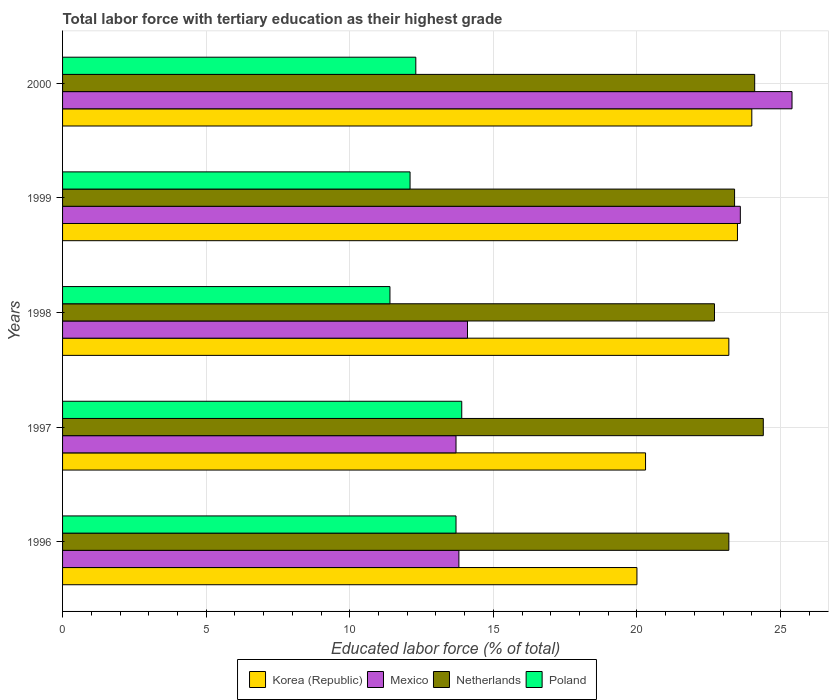How many different coloured bars are there?
Your answer should be compact. 4. How many groups of bars are there?
Your answer should be compact. 5. Are the number of bars per tick equal to the number of legend labels?
Make the answer very short. Yes. In how many cases, is the number of bars for a given year not equal to the number of legend labels?
Make the answer very short. 0. What is the percentage of male labor force with tertiary education in Mexico in 1997?
Offer a very short reply. 13.7. Across all years, what is the maximum percentage of male labor force with tertiary education in Korea (Republic)?
Offer a very short reply. 24. Across all years, what is the minimum percentage of male labor force with tertiary education in Mexico?
Give a very brief answer. 13.7. In which year was the percentage of male labor force with tertiary education in Poland maximum?
Offer a very short reply. 1997. In which year was the percentage of male labor force with tertiary education in Mexico minimum?
Offer a very short reply. 1997. What is the total percentage of male labor force with tertiary education in Poland in the graph?
Make the answer very short. 63.4. What is the difference between the percentage of male labor force with tertiary education in Poland in 1996 and that in 1998?
Offer a very short reply. 2.3. What is the difference between the percentage of male labor force with tertiary education in Mexico in 1996 and the percentage of male labor force with tertiary education in Netherlands in 1998?
Ensure brevity in your answer.  -8.9. In the year 1998, what is the difference between the percentage of male labor force with tertiary education in Netherlands and percentage of male labor force with tertiary education in Poland?
Ensure brevity in your answer.  11.3. What is the ratio of the percentage of male labor force with tertiary education in Poland in 1997 to that in 1998?
Offer a terse response. 1.22. Is the percentage of male labor force with tertiary education in Mexico in 1997 less than that in 2000?
Make the answer very short. Yes. What is the difference between the highest and the second highest percentage of male labor force with tertiary education in Korea (Republic)?
Provide a short and direct response. 0.5. What is the difference between the highest and the lowest percentage of male labor force with tertiary education in Korea (Republic)?
Make the answer very short. 4. Is the sum of the percentage of male labor force with tertiary education in Mexico in 1996 and 1997 greater than the maximum percentage of male labor force with tertiary education in Poland across all years?
Provide a succinct answer. Yes. Is it the case that in every year, the sum of the percentage of male labor force with tertiary education in Poland and percentage of male labor force with tertiary education in Korea (Republic) is greater than the sum of percentage of male labor force with tertiary education in Mexico and percentage of male labor force with tertiary education in Netherlands?
Your answer should be very brief. Yes. Are all the bars in the graph horizontal?
Your answer should be very brief. Yes. What is the difference between two consecutive major ticks on the X-axis?
Ensure brevity in your answer.  5. Does the graph contain any zero values?
Make the answer very short. No. Does the graph contain grids?
Provide a succinct answer. Yes. How many legend labels are there?
Provide a succinct answer. 4. How are the legend labels stacked?
Your answer should be compact. Horizontal. What is the title of the graph?
Offer a very short reply. Total labor force with tertiary education as their highest grade. Does "Niger" appear as one of the legend labels in the graph?
Offer a terse response. No. What is the label or title of the X-axis?
Your response must be concise. Educated labor force (% of total). What is the label or title of the Y-axis?
Your answer should be compact. Years. What is the Educated labor force (% of total) in Mexico in 1996?
Make the answer very short. 13.8. What is the Educated labor force (% of total) of Netherlands in 1996?
Your response must be concise. 23.2. What is the Educated labor force (% of total) in Poland in 1996?
Your response must be concise. 13.7. What is the Educated labor force (% of total) in Korea (Republic) in 1997?
Your answer should be very brief. 20.3. What is the Educated labor force (% of total) in Mexico in 1997?
Ensure brevity in your answer.  13.7. What is the Educated labor force (% of total) of Netherlands in 1997?
Ensure brevity in your answer.  24.4. What is the Educated labor force (% of total) of Poland in 1997?
Keep it short and to the point. 13.9. What is the Educated labor force (% of total) of Korea (Republic) in 1998?
Provide a succinct answer. 23.2. What is the Educated labor force (% of total) in Mexico in 1998?
Your answer should be compact. 14.1. What is the Educated labor force (% of total) in Netherlands in 1998?
Provide a short and direct response. 22.7. What is the Educated labor force (% of total) in Poland in 1998?
Your answer should be very brief. 11.4. What is the Educated labor force (% of total) in Korea (Republic) in 1999?
Your answer should be compact. 23.5. What is the Educated labor force (% of total) of Mexico in 1999?
Make the answer very short. 23.6. What is the Educated labor force (% of total) of Netherlands in 1999?
Offer a very short reply. 23.4. What is the Educated labor force (% of total) in Poland in 1999?
Give a very brief answer. 12.1. What is the Educated labor force (% of total) in Korea (Republic) in 2000?
Give a very brief answer. 24. What is the Educated labor force (% of total) of Mexico in 2000?
Offer a very short reply. 25.4. What is the Educated labor force (% of total) of Netherlands in 2000?
Provide a succinct answer. 24.1. What is the Educated labor force (% of total) of Poland in 2000?
Your answer should be compact. 12.3. Across all years, what is the maximum Educated labor force (% of total) of Korea (Republic)?
Offer a very short reply. 24. Across all years, what is the maximum Educated labor force (% of total) in Mexico?
Keep it short and to the point. 25.4. Across all years, what is the maximum Educated labor force (% of total) of Netherlands?
Your answer should be very brief. 24.4. Across all years, what is the maximum Educated labor force (% of total) of Poland?
Provide a succinct answer. 13.9. Across all years, what is the minimum Educated labor force (% of total) in Korea (Republic)?
Make the answer very short. 20. Across all years, what is the minimum Educated labor force (% of total) of Mexico?
Provide a short and direct response. 13.7. Across all years, what is the minimum Educated labor force (% of total) of Netherlands?
Provide a succinct answer. 22.7. Across all years, what is the minimum Educated labor force (% of total) in Poland?
Provide a succinct answer. 11.4. What is the total Educated labor force (% of total) in Korea (Republic) in the graph?
Offer a terse response. 111. What is the total Educated labor force (% of total) in Mexico in the graph?
Your response must be concise. 90.6. What is the total Educated labor force (% of total) in Netherlands in the graph?
Your answer should be very brief. 117.8. What is the total Educated labor force (% of total) in Poland in the graph?
Offer a terse response. 63.4. What is the difference between the Educated labor force (% of total) of Korea (Republic) in 1996 and that in 1997?
Give a very brief answer. -0.3. What is the difference between the Educated labor force (% of total) in Mexico in 1996 and that in 1997?
Provide a short and direct response. 0.1. What is the difference between the Educated labor force (% of total) of Poland in 1996 and that in 1997?
Give a very brief answer. -0.2. What is the difference between the Educated labor force (% of total) of Korea (Republic) in 1996 and that in 1998?
Your answer should be compact. -3.2. What is the difference between the Educated labor force (% of total) in Netherlands in 1996 and that in 1998?
Your answer should be very brief. 0.5. What is the difference between the Educated labor force (% of total) of Poland in 1996 and that in 1998?
Make the answer very short. 2.3. What is the difference between the Educated labor force (% of total) of Korea (Republic) in 1996 and that in 1999?
Make the answer very short. -3.5. What is the difference between the Educated labor force (% of total) of Mexico in 1996 and that in 1999?
Your response must be concise. -9.8. What is the difference between the Educated labor force (% of total) in Poland in 1996 and that in 1999?
Your response must be concise. 1.6. What is the difference between the Educated labor force (% of total) in Korea (Republic) in 1996 and that in 2000?
Your answer should be very brief. -4. What is the difference between the Educated labor force (% of total) of Netherlands in 1996 and that in 2000?
Ensure brevity in your answer.  -0.9. What is the difference between the Educated labor force (% of total) of Poland in 1996 and that in 2000?
Offer a terse response. 1.4. What is the difference between the Educated labor force (% of total) of Korea (Republic) in 1997 and that in 1999?
Offer a terse response. -3.2. What is the difference between the Educated labor force (% of total) in Mexico in 1997 and that in 1999?
Your response must be concise. -9.9. What is the difference between the Educated labor force (% of total) in Netherlands in 1997 and that in 1999?
Ensure brevity in your answer.  1. What is the difference between the Educated labor force (% of total) in Poland in 1997 and that in 1999?
Your response must be concise. 1.8. What is the difference between the Educated labor force (% of total) of Korea (Republic) in 1997 and that in 2000?
Offer a terse response. -3.7. What is the difference between the Educated labor force (% of total) in Netherlands in 1997 and that in 2000?
Your answer should be compact. 0.3. What is the difference between the Educated labor force (% of total) in Poland in 1997 and that in 2000?
Provide a succinct answer. 1.6. What is the difference between the Educated labor force (% of total) of Mexico in 1998 and that in 2000?
Your response must be concise. -11.3. What is the difference between the Educated labor force (% of total) of Netherlands in 1998 and that in 2000?
Provide a short and direct response. -1.4. What is the difference between the Educated labor force (% of total) in Poland in 1998 and that in 2000?
Provide a short and direct response. -0.9. What is the difference between the Educated labor force (% of total) of Mexico in 1999 and that in 2000?
Give a very brief answer. -1.8. What is the difference between the Educated labor force (% of total) of Korea (Republic) in 1996 and the Educated labor force (% of total) of Mexico in 1997?
Make the answer very short. 6.3. What is the difference between the Educated labor force (% of total) of Korea (Republic) in 1996 and the Educated labor force (% of total) of Netherlands in 1997?
Ensure brevity in your answer.  -4.4. What is the difference between the Educated labor force (% of total) in Korea (Republic) in 1996 and the Educated labor force (% of total) in Poland in 1997?
Provide a short and direct response. 6.1. What is the difference between the Educated labor force (% of total) in Korea (Republic) in 1996 and the Educated labor force (% of total) in Netherlands in 1998?
Offer a terse response. -2.7. What is the difference between the Educated labor force (% of total) in Mexico in 1996 and the Educated labor force (% of total) in Netherlands in 1998?
Ensure brevity in your answer.  -8.9. What is the difference between the Educated labor force (% of total) in Mexico in 1996 and the Educated labor force (% of total) in Poland in 1998?
Make the answer very short. 2.4. What is the difference between the Educated labor force (% of total) in Netherlands in 1996 and the Educated labor force (% of total) in Poland in 1998?
Provide a succinct answer. 11.8. What is the difference between the Educated labor force (% of total) of Korea (Republic) in 1996 and the Educated labor force (% of total) of Mexico in 1999?
Keep it short and to the point. -3.6. What is the difference between the Educated labor force (% of total) in Mexico in 1996 and the Educated labor force (% of total) in Netherlands in 1999?
Your answer should be compact. -9.6. What is the difference between the Educated labor force (% of total) of Korea (Republic) in 1996 and the Educated labor force (% of total) of Netherlands in 2000?
Your response must be concise. -4.1. What is the difference between the Educated labor force (% of total) in Mexico in 1996 and the Educated labor force (% of total) in Netherlands in 2000?
Keep it short and to the point. -10.3. What is the difference between the Educated labor force (% of total) of Mexico in 1996 and the Educated labor force (% of total) of Poland in 2000?
Provide a succinct answer. 1.5. What is the difference between the Educated labor force (% of total) in Korea (Republic) in 1997 and the Educated labor force (% of total) in Mexico in 1998?
Your response must be concise. 6.2. What is the difference between the Educated labor force (% of total) of Korea (Republic) in 1997 and the Educated labor force (% of total) of Poland in 1998?
Your answer should be compact. 8.9. What is the difference between the Educated labor force (% of total) of Mexico in 1997 and the Educated labor force (% of total) of Netherlands in 1998?
Make the answer very short. -9. What is the difference between the Educated labor force (% of total) of Korea (Republic) in 1997 and the Educated labor force (% of total) of Netherlands in 1999?
Your answer should be compact. -3.1. What is the difference between the Educated labor force (% of total) in Mexico in 1997 and the Educated labor force (% of total) in Netherlands in 2000?
Provide a short and direct response. -10.4. What is the difference between the Educated labor force (% of total) in Mexico in 1997 and the Educated labor force (% of total) in Poland in 2000?
Give a very brief answer. 1.4. What is the difference between the Educated labor force (% of total) of Korea (Republic) in 1998 and the Educated labor force (% of total) of Poland in 1999?
Your answer should be compact. 11.1. What is the difference between the Educated labor force (% of total) of Mexico in 1998 and the Educated labor force (% of total) of Poland in 1999?
Provide a succinct answer. 2. What is the difference between the Educated labor force (% of total) in Korea (Republic) in 1998 and the Educated labor force (% of total) in Netherlands in 2000?
Keep it short and to the point. -0.9. What is the difference between the Educated labor force (% of total) in Korea (Republic) in 1998 and the Educated labor force (% of total) in Poland in 2000?
Your answer should be compact. 10.9. What is the difference between the Educated labor force (% of total) of Netherlands in 1998 and the Educated labor force (% of total) of Poland in 2000?
Keep it short and to the point. 10.4. What is the difference between the Educated labor force (% of total) in Korea (Republic) in 1999 and the Educated labor force (% of total) in Netherlands in 2000?
Your response must be concise. -0.6. What is the difference between the Educated labor force (% of total) of Korea (Republic) in 1999 and the Educated labor force (% of total) of Poland in 2000?
Keep it short and to the point. 11.2. What is the difference between the Educated labor force (% of total) of Mexico in 1999 and the Educated labor force (% of total) of Netherlands in 2000?
Make the answer very short. -0.5. What is the difference between the Educated labor force (% of total) in Mexico in 1999 and the Educated labor force (% of total) in Poland in 2000?
Offer a very short reply. 11.3. What is the difference between the Educated labor force (% of total) in Netherlands in 1999 and the Educated labor force (% of total) in Poland in 2000?
Make the answer very short. 11.1. What is the average Educated labor force (% of total) in Korea (Republic) per year?
Offer a very short reply. 22.2. What is the average Educated labor force (% of total) in Mexico per year?
Make the answer very short. 18.12. What is the average Educated labor force (% of total) in Netherlands per year?
Provide a short and direct response. 23.56. What is the average Educated labor force (% of total) of Poland per year?
Offer a terse response. 12.68. In the year 1996, what is the difference between the Educated labor force (% of total) of Korea (Republic) and Educated labor force (% of total) of Netherlands?
Provide a succinct answer. -3.2. In the year 1996, what is the difference between the Educated labor force (% of total) in Korea (Republic) and Educated labor force (% of total) in Poland?
Your answer should be compact. 6.3. In the year 1996, what is the difference between the Educated labor force (% of total) in Mexico and Educated labor force (% of total) in Netherlands?
Provide a succinct answer. -9.4. In the year 1996, what is the difference between the Educated labor force (% of total) of Mexico and Educated labor force (% of total) of Poland?
Keep it short and to the point. 0.1. In the year 1996, what is the difference between the Educated labor force (% of total) of Netherlands and Educated labor force (% of total) of Poland?
Provide a short and direct response. 9.5. In the year 1997, what is the difference between the Educated labor force (% of total) in Korea (Republic) and Educated labor force (% of total) in Mexico?
Give a very brief answer. 6.6. In the year 1997, what is the difference between the Educated labor force (% of total) in Korea (Republic) and Educated labor force (% of total) in Netherlands?
Your response must be concise. -4.1. In the year 1997, what is the difference between the Educated labor force (% of total) in Korea (Republic) and Educated labor force (% of total) in Poland?
Ensure brevity in your answer.  6.4. In the year 1997, what is the difference between the Educated labor force (% of total) of Mexico and Educated labor force (% of total) of Poland?
Keep it short and to the point. -0.2. In the year 1998, what is the difference between the Educated labor force (% of total) in Korea (Republic) and Educated labor force (% of total) in Mexico?
Provide a short and direct response. 9.1. In the year 1998, what is the difference between the Educated labor force (% of total) in Korea (Republic) and Educated labor force (% of total) in Netherlands?
Provide a short and direct response. 0.5. In the year 1998, what is the difference between the Educated labor force (% of total) of Korea (Republic) and Educated labor force (% of total) of Poland?
Keep it short and to the point. 11.8. In the year 1998, what is the difference between the Educated labor force (% of total) of Netherlands and Educated labor force (% of total) of Poland?
Offer a terse response. 11.3. In the year 1999, what is the difference between the Educated labor force (% of total) in Korea (Republic) and Educated labor force (% of total) in Netherlands?
Provide a succinct answer. 0.1. In the year 1999, what is the difference between the Educated labor force (% of total) of Mexico and Educated labor force (% of total) of Poland?
Offer a very short reply. 11.5. In the year 1999, what is the difference between the Educated labor force (% of total) of Netherlands and Educated labor force (% of total) of Poland?
Offer a terse response. 11.3. In the year 2000, what is the difference between the Educated labor force (% of total) in Korea (Republic) and Educated labor force (% of total) in Mexico?
Offer a terse response. -1.4. In the year 2000, what is the difference between the Educated labor force (% of total) of Korea (Republic) and Educated labor force (% of total) of Netherlands?
Make the answer very short. -0.1. In the year 2000, what is the difference between the Educated labor force (% of total) in Korea (Republic) and Educated labor force (% of total) in Poland?
Ensure brevity in your answer.  11.7. In the year 2000, what is the difference between the Educated labor force (% of total) of Mexico and Educated labor force (% of total) of Poland?
Your answer should be very brief. 13.1. What is the ratio of the Educated labor force (% of total) in Korea (Republic) in 1996 to that in 1997?
Ensure brevity in your answer.  0.99. What is the ratio of the Educated labor force (% of total) of Mexico in 1996 to that in 1997?
Offer a very short reply. 1.01. What is the ratio of the Educated labor force (% of total) in Netherlands in 1996 to that in 1997?
Make the answer very short. 0.95. What is the ratio of the Educated labor force (% of total) of Poland in 1996 to that in 1997?
Ensure brevity in your answer.  0.99. What is the ratio of the Educated labor force (% of total) in Korea (Republic) in 1996 to that in 1998?
Give a very brief answer. 0.86. What is the ratio of the Educated labor force (% of total) in Mexico in 1996 to that in 1998?
Provide a short and direct response. 0.98. What is the ratio of the Educated labor force (% of total) in Poland in 1996 to that in 1998?
Provide a succinct answer. 1.2. What is the ratio of the Educated labor force (% of total) in Korea (Republic) in 1996 to that in 1999?
Your answer should be very brief. 0.85. What is the ratio of the Educated labor force (% of total) of Mexico in 1996 to that in 1999?
Offer a very short reply. 0.58. What is the ratio of the Educated labor force (% of total) of Poland in 1996 to that in 1999?
Your answer should be compact. 1.13. What is the ratio of the Educated labor force (% of total) in Mexico in 1996 to that in 2000?
Ensure brevity in your answer.  0.54. What is the ratio of the Educated labor force (% of total) in Netherlands in 1996 to that in 2000?
Offer a terse response. 0.96. What is the ratio of the Educated labor force (% of total) of Poland in 1996 to that in 2000?
Offer a very short reply. 1.11. What is the ratio of the Educated labor force (% of total) of Mexico in 1997 to that in 1998?
Offer a terse response. 0.97. What is the ratio of the Educated labor force (% of total) of Netherlands in 1997 to that in 1998?
Your answer should be very brief. 1.07. What is the ratio of the Educated labor force (% of total) of Poland in 1997 to that in 1998?
Your answer should be compact. 1.22. What is the ratio of the Educated labor force (% of total) in Korea (Republic) in 1997 to that in 1999?
Ensure brevity in your answer.  0.86. What is the ratio of the Educated labor force (% of total) of Mexico in 1997 to that in 1999?
Offer a very short reply. 0.58. What is the ratio of the Educated labor force (% of total) in Netherlands in 1997 to that in 1999?
Your answer should be very brief. 1.04. What is the ratio of the Educated labor force (% of total) in Poland in 1997 to that in 1999?
Offer a very short reply. 1.15. What is the ratio of the Educated labor force (% of total) of Korea (Republic) in 1997 to that in 2000?
Provide a succinct answer. 0.85. What is the ratio of the Educated labor force (% of total) in Mexico in 1997 to that in 2000?
Your response must be concise. 0.54. What is the ratio of the Educated labor force (% of total) in Netherlands in 1997 to that in 2000?
Your answer should be very brief. 1.01. What is the ratio of the Educated labor force (% of total) of Poland in 1997 to that in 2000?
Offer a terse response. 1.13. What is the ratio of the Educated labor force (% of total) in Korea (Republic) in 1998 to that in 1999?
Provide a short and direct response. 0.99. What is the ratio of the Educated labor force (% of total) of Mexico in 1998 to that in 1999?
Your answer should be very brief. 0.6. What is the ratio of the Educated labor force (% of total) of Netherlands in 1998 to that in 1999?
Your answer should be very brief. 0.97. What is the ratio of the Educated labor force (% of total) of Poland in 1998 to that in 1999?
Your answer should be very brief. 0.94. What is the ratio of the Educated labor force (% of total) in Korea (Republic) in 1998 to that in 2000?
Your response must be concise. 0.97. What is the ratio of the Educated labor force (% of total) in Mexico in 1998 to that in 2000?
Ensure brevity in your answer.  0.56. What is the ratio of the Educated labor force (% of total) of Netherlands in 1998 to that in 2000?
Give a very brief answer. 0.94. What is the ratio of the Educated labor force (% of total) of Poland in 1998 to that in 2000?
Ensure brevity in your answer.  0.93. What is the ratio of the Educated labor force (% of total) of Korea (Republic) in 1999 to that in 2000?
Make the answer very short. 0.98. What is the ratio of the Educated labor force (% of total) of Mexico in 1999 to that in 2000?
Ensure brevity in your answer.  0.93. What is the ratio of the Educated labor force (% of total) of Netherlands in 1999 to that in 2000?
Your answer should be very brief. 0.97. What is the ratio of the Educated labor force (% of total) of Poland in 1999 to that in 2000?
Your answer should be very brief. 0.98. What is the difference between the highest and the second highest Educated labor force (% of total) of Mexico?
Make the answer very short. 1.8. What is the difference between the highest and the second highest Educated labor force (% of total) of Poland?
Make the answer very short. 0.2. What is the difference between the highest and the lowest Educated labor force (% of total) in Korea (Republic)?
Provide a succinct answer. 4. What is the difference between the highest and the lowest Educated labor force (% of total) of Netherlands?
Ensure brevity in your answer.  1.7. 